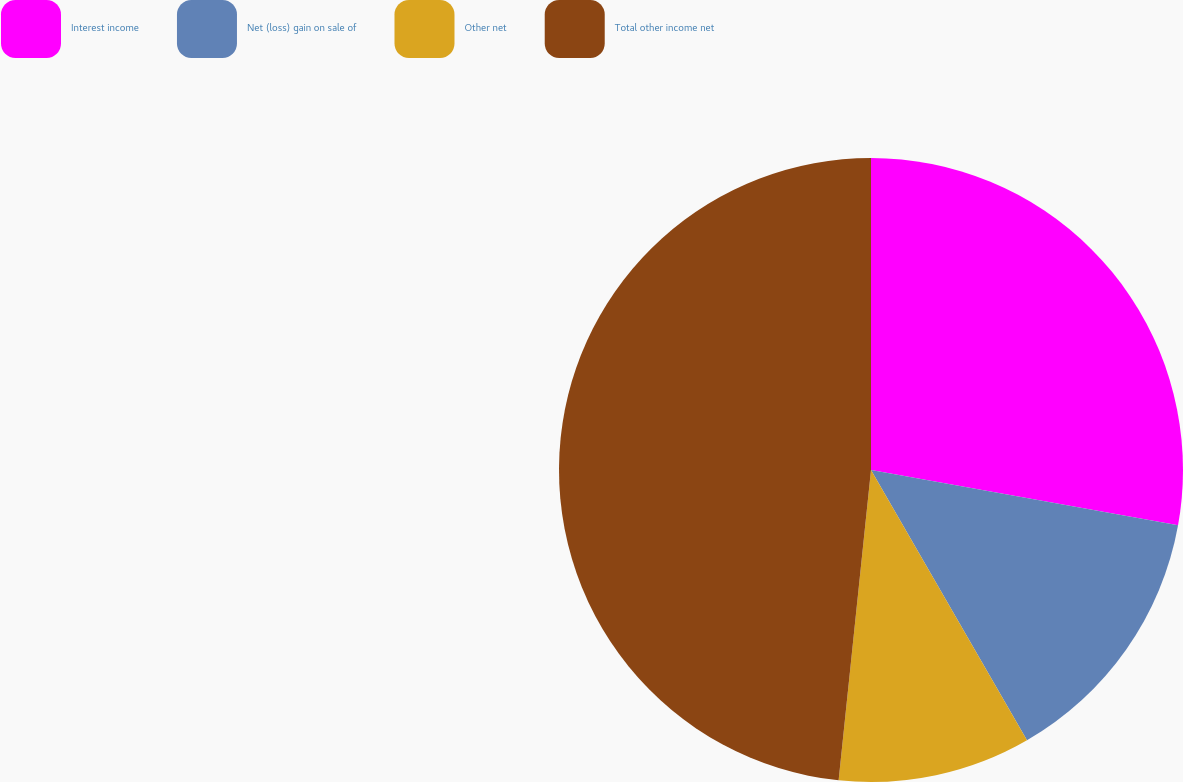<chart> <loc_0><loc_0><loc_500><loc_500><pie_chart><fcel>Interest income<fcel>Net (loss) gain on sale of<fcel>Other net<fcel>Total other income net<nl><fcel>27.84%<fcel>13.83%<fcel>9.99%<fcel>48.35%<nl></chart> 